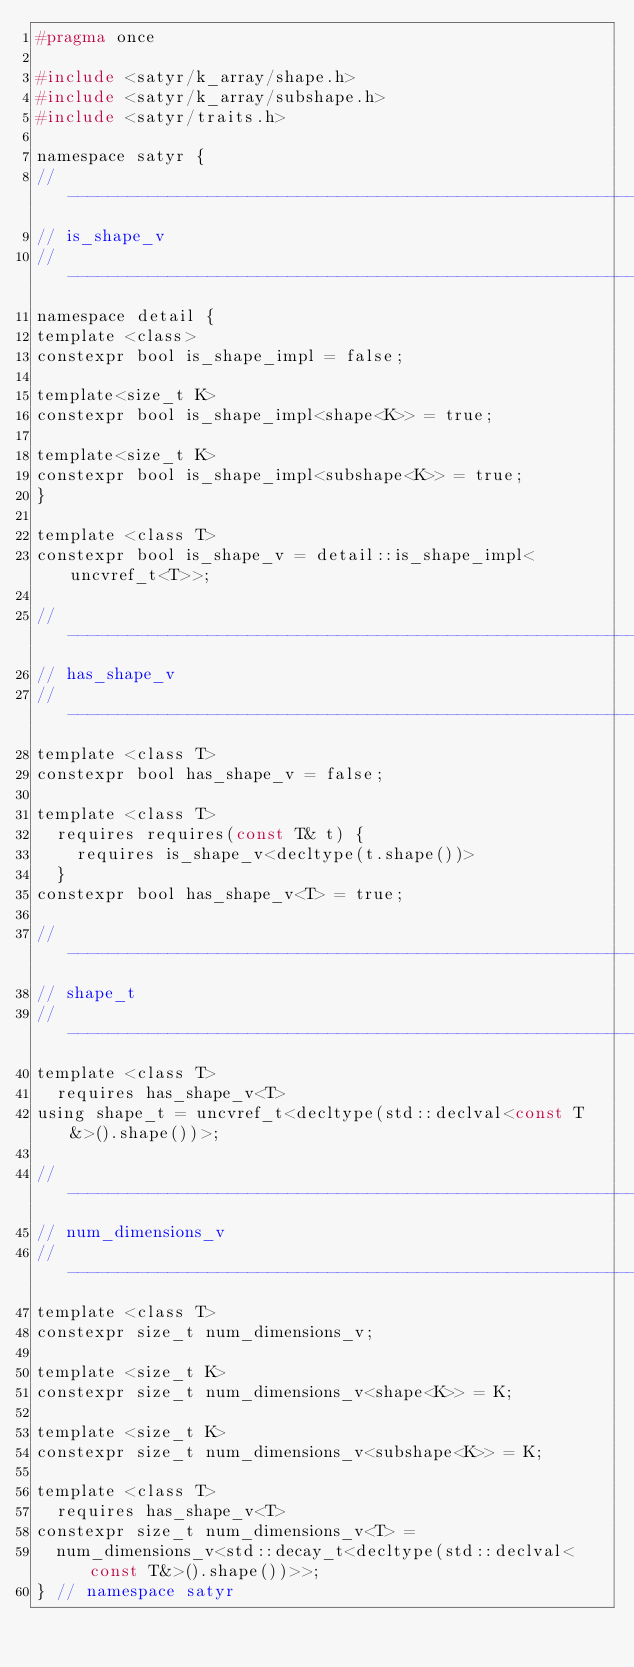<code> <loc_0><loc_0><loc_500><loc_500><_C_>#pragma once

#include <satyr/k_array/shape.h>
#include <satyr/k_array/subshape.h>
#include <satyr/traits.h>

namespace satyr {
//------------------------------------------------------------------------------
// is_shape_v
//------------------------------------------------------------------------------
namespace detail {
template <class>
constexpr bool is_shape_impl = false;

template<size_t K>
constexpr bool is_shape_impl<shape<K>> = true;

template<size_t K>
constexpr bool is_shape_impl<subshape<K>> = true;
}

template <class T>
constexpr bool is_shape_v = detail::is_shape_impl<uncvref_t<T>>;

//------------------------------------------------------------------------------
// has_shape_v
//------------------------------------------------------------------------------
template <class T>
constexpr bool has_shape_v = false;

template <class T>
  requires requires(const T& t) {
    requires is_shape_v<decltype(t.shape())>
  }
constexpr bool has_shape_v<T> = true;

//------------------------------------------------------------------------------
// shape_t
//------------------------------------------------------------------------------
template <class T>
  requires has_shape_v<T>
using shape_t = uncvref_t<decltype(std::declval<const T&>().shape())>;

//------------------------------------------------------------------------------
// num_dimensions_v
//------------------------------------------------------------------------------
template <class T>
constexpr size_t num_dimensions_v;

template <size_t K>
constexpr size_t num_dimensions_v<shape<K>> = K;

template <size_t K>
constexpr size_t num_dimensions_v<subshape<K>> = K;

template <class T>
  requires has_shape_v<T>
constexpr size_t num_dimensions_v<T> = 
  num_dimensions_v<std::decay_t<decltype(std::declval<const T&>().shape())>>;
} // namespace satyr
</code> 